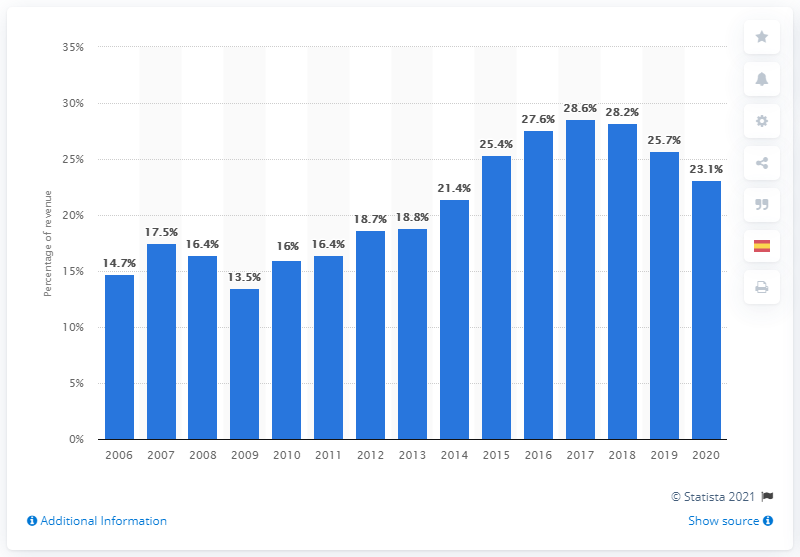Point out several critical features in this image. In 2020, AstraZeneca invested 23.1% of its revenue in research and development. 